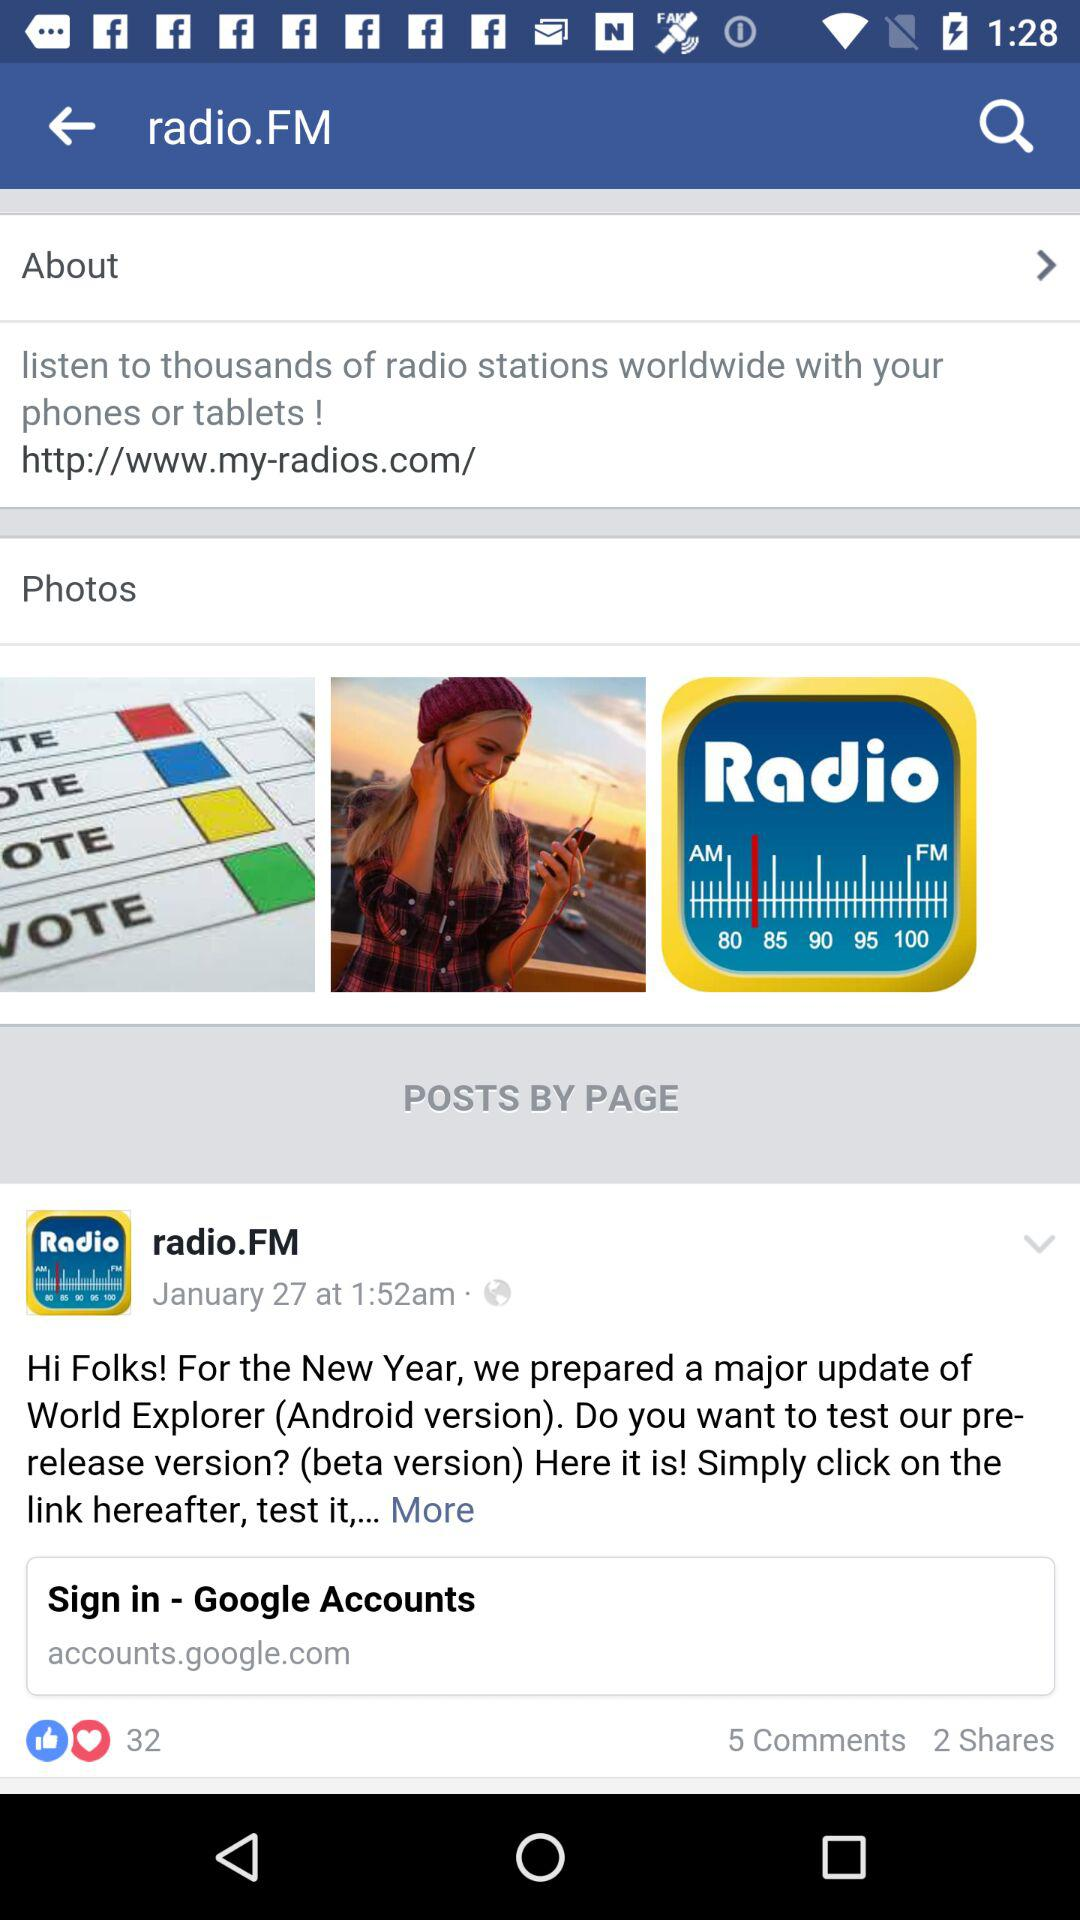What is the given Google account address? The given Google account address is accounts.google.com. 